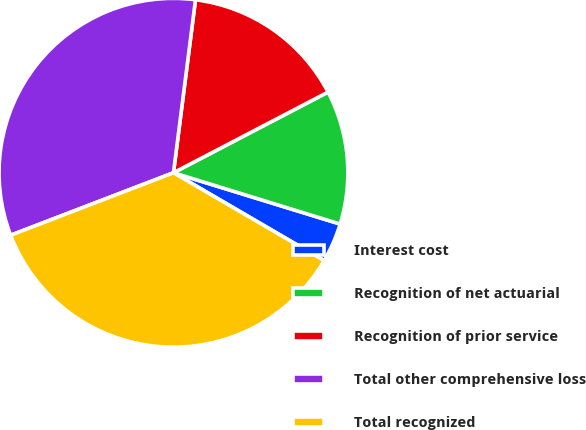Convert chart to OTSL. <chart><loc_0><loc_0><loc_500><loc_500><pie_chart><fcel>Interest cost<fcel>Recognition of net actuarial<fcel>Recognition of prior service<fcel>Total other comprehensive loss<fcel>Total recognized<nl><fcel>3.65%<fcel>12.41%<fcel>15.33%<fcel>32.85%<fcel>35.77%<nl></chart> 